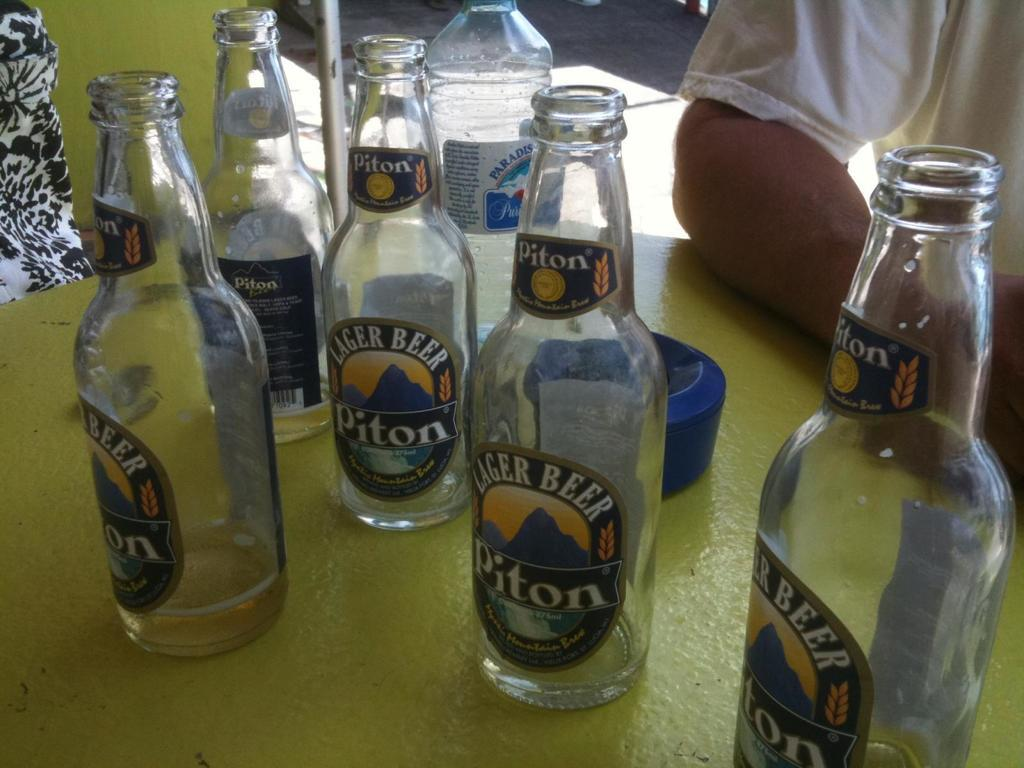Provide a one-sentence caption for the provided image. Piton lager beer bottles sit empty on a table. 